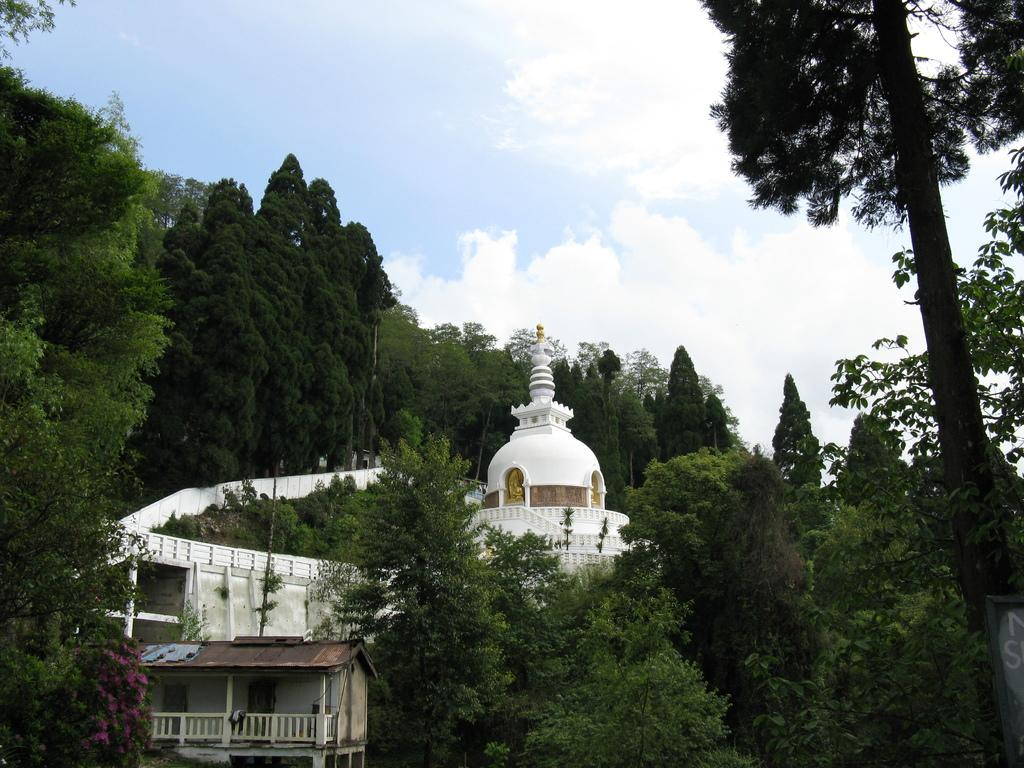What type of structures are present in the image? There are buildings in the image. What other natural elements can be seen in the image? There are trees in the image. Where is the text located in the image? The text is on a board on the right side of the image. What is visible at the top of the image? The sky is visible at the top of the image. How many ice cubes are floating in the sky in the image? There are no ice cubes present in the image; the sky is visible without any ice. 